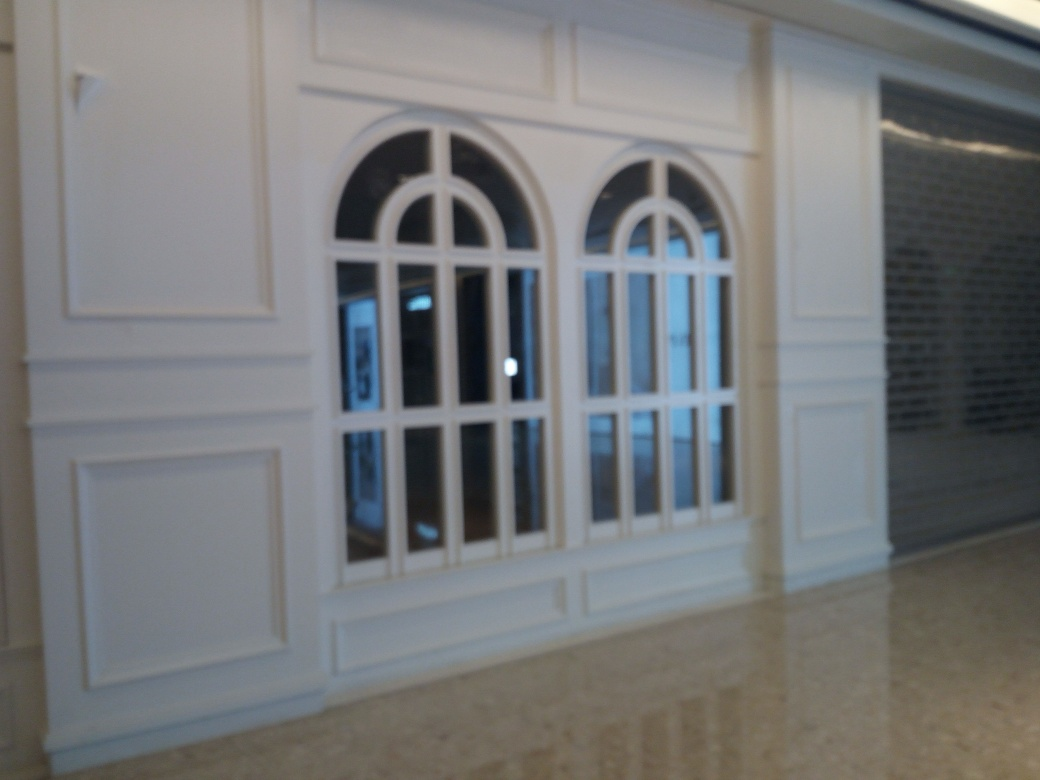Can you tell what the material of the floor might be? Although the image is not in perfect focus, the floor appears to be polished marble or a similar stone, given its reflective sheen and subtle variations in color. 